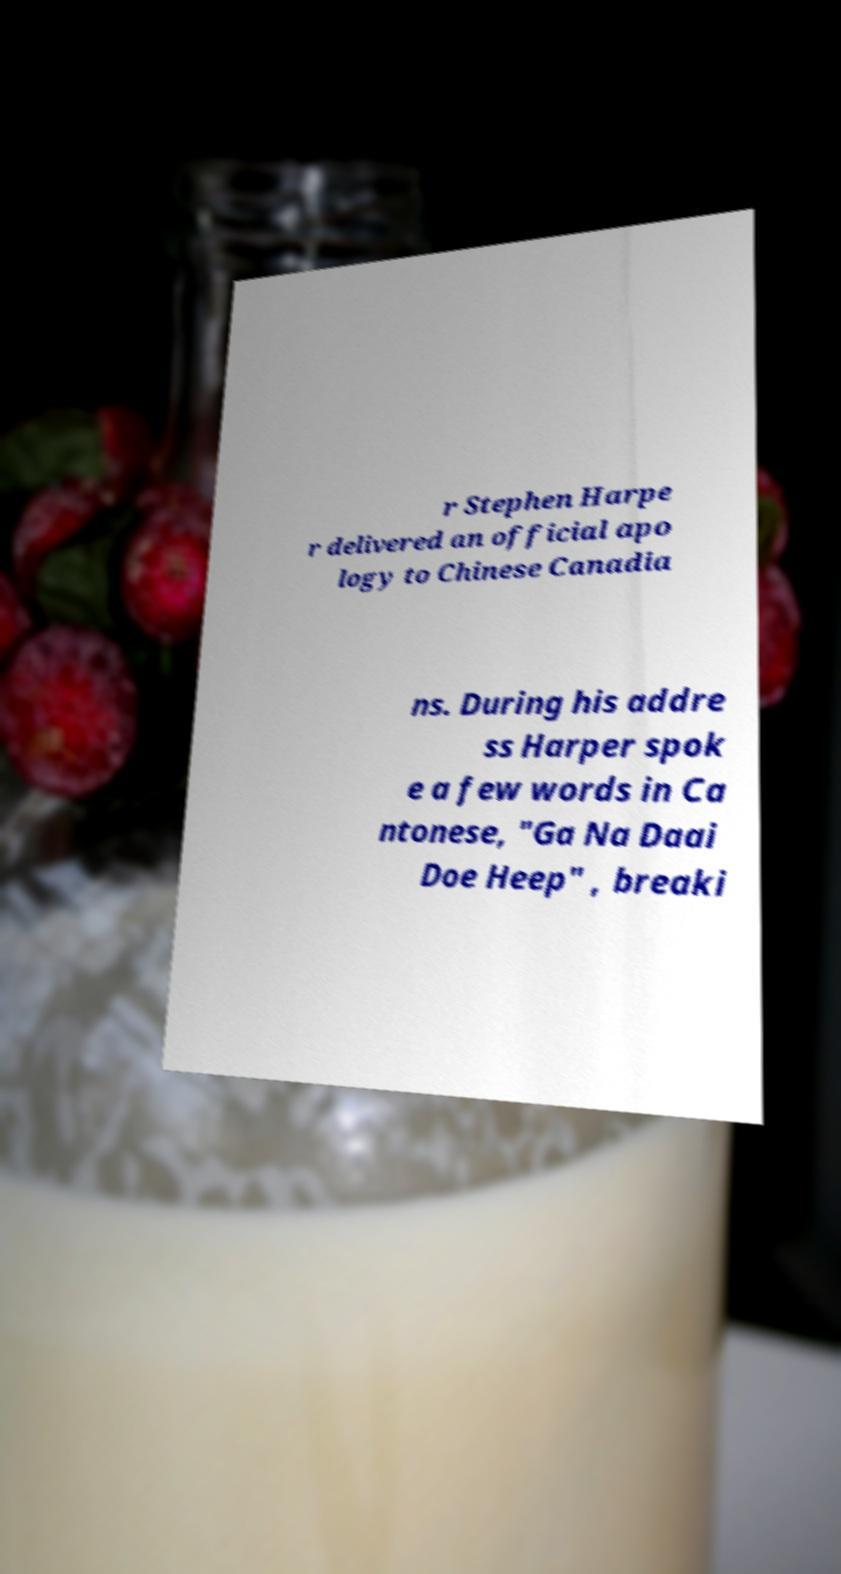Could you assist in decoding the text presented in this image and type it out clearly? r Stephen Harpe r delivered an official apo logy to Chinese Canadia ns. During his addre ss Harper spok e a few words in Ca ntonese, "Ga Na Daai Doe Heep" , breaki 